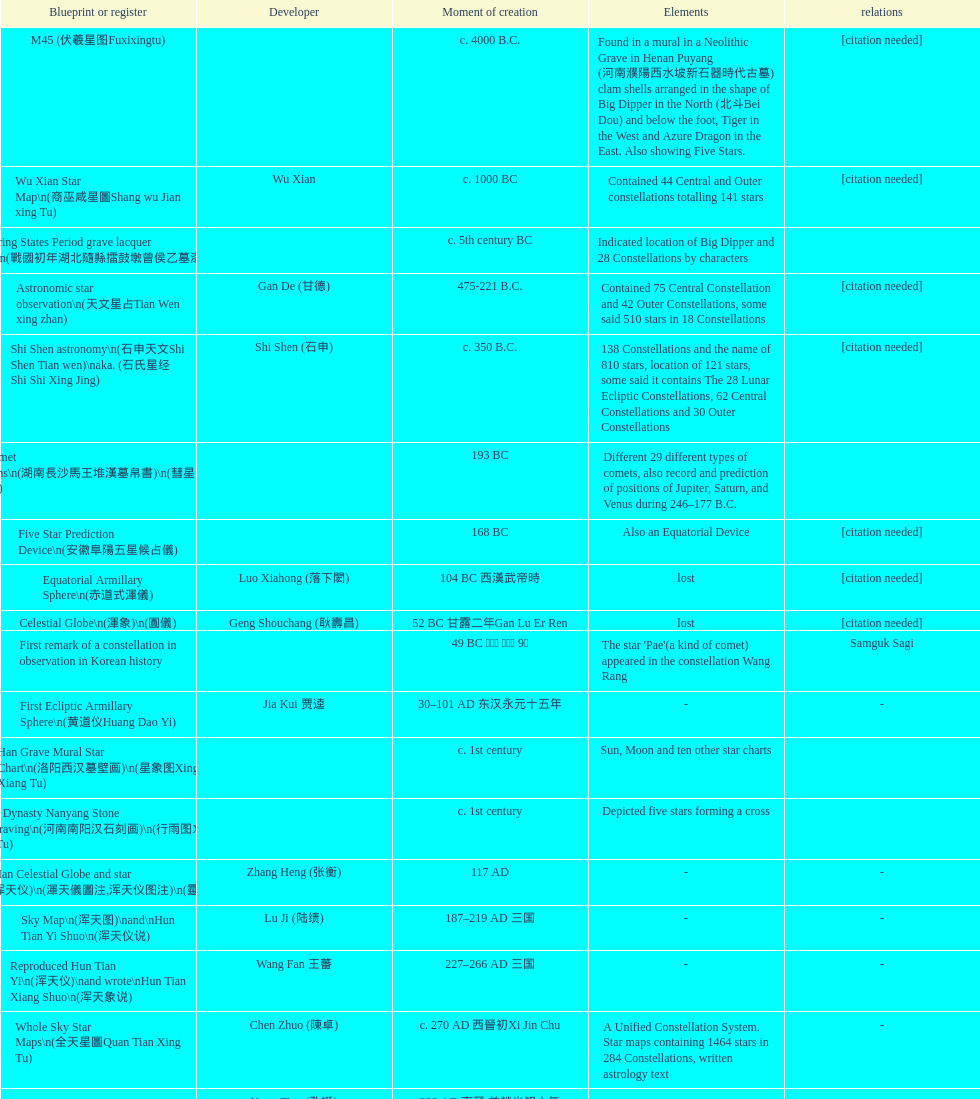What is the difference between the five star prediction device's date of creation and the han comet diagrams' date of creation? 25 years. 